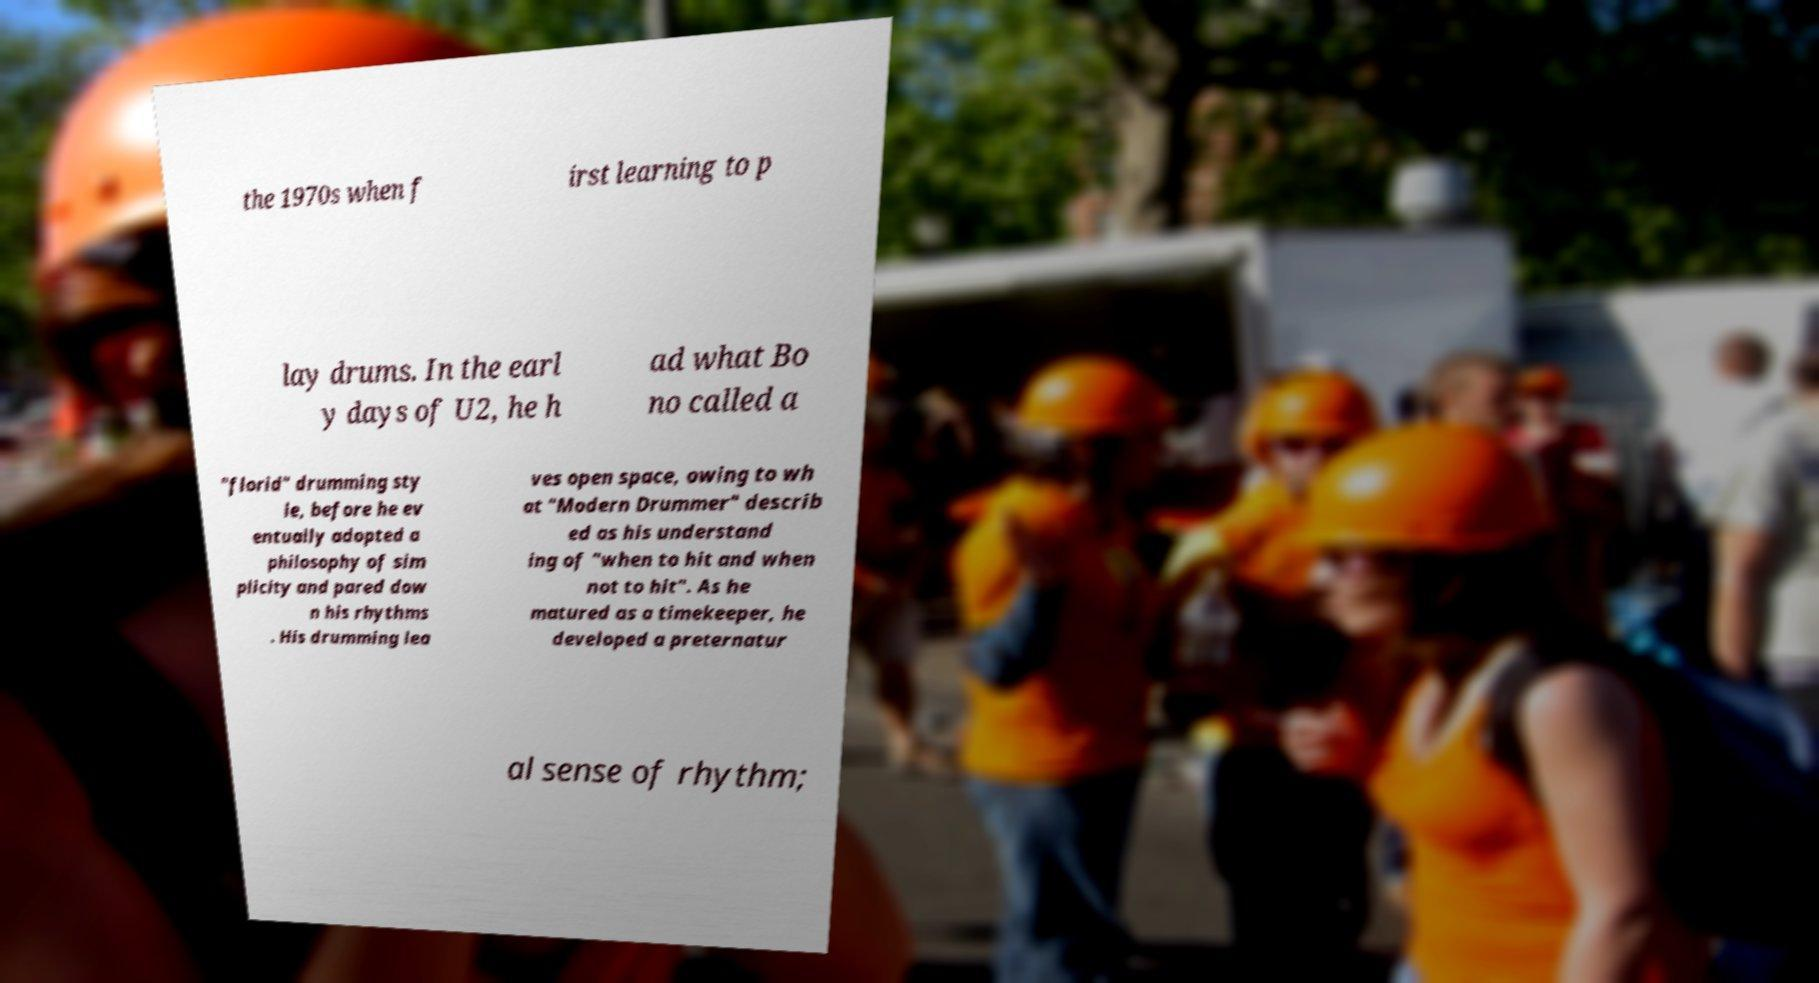I need the written content from this picture converted into text. Can you do that? the 1970s when f irst learning to p lay drums. In the earl y days of U2, he h ad what Bo no called a "florid" drumming sty le, before he ev entually adopted a philosophy of sim plicity and pared dow n his rhythms . His drumming lea ves open space, owing to wh at "Modern Drummer" describ ed as his understand ing of "when to hit and when not to hit". As he matured as a timekeeper, he developed a preternatur al sense of rhythm; 